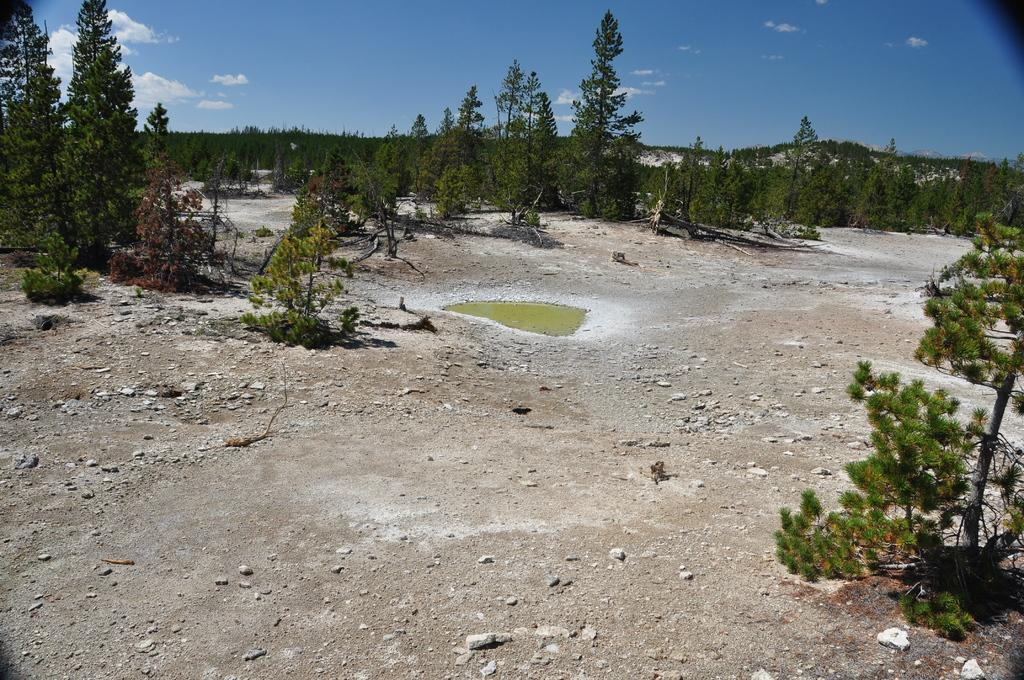What is located in the middle of the image? There is water in the middle of the image. What can be seen in the background of the image? There are groups of trees in the background. What is visible in the sky in the image? There are clouds in the sky. What caption is written on the image? There is no caption present in the image. What observation can be made about the time of day in the image? The provided facts do not give any information about the time of day, so it cannot be determined from the image. 